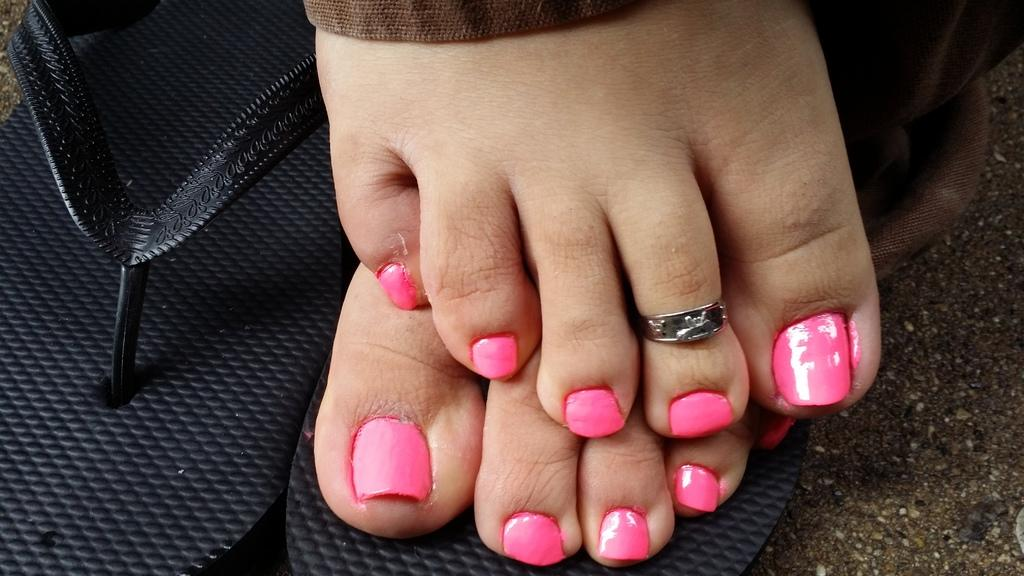What is the main focus of the image? The image shows a close view of a woman's legs. What can be observed about the woman's nails in the image? The woman has pink nail polish on her nails. What type of footwear is the woman wearing in the image? There are black flip flops visible in the image. How many chairs are present in the image? There are no chairs visible in the image; it focuses on the woman's legs and feet. What type of conversation is taking place at the meeting in the image? There is no meeting or conversation present in the image; it only shows a close view of the woman's legs and feet. 